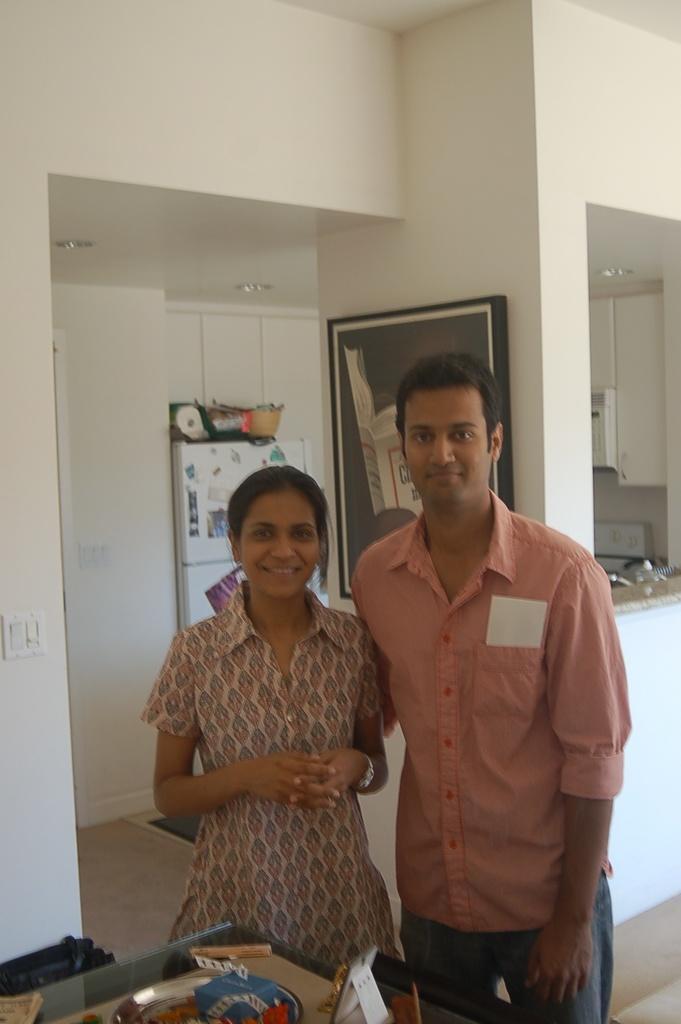Please provide a concise description of this image. This image is taken indoors. In the background there are a few walls and there is a picture frame on the wall. On the right side of the image there is a kitchen platform with a few things on it. In the middle of the image a man and a woman are standing on the floor and there is a fridge. At the bottom of the image there is a table with a few things on it. 